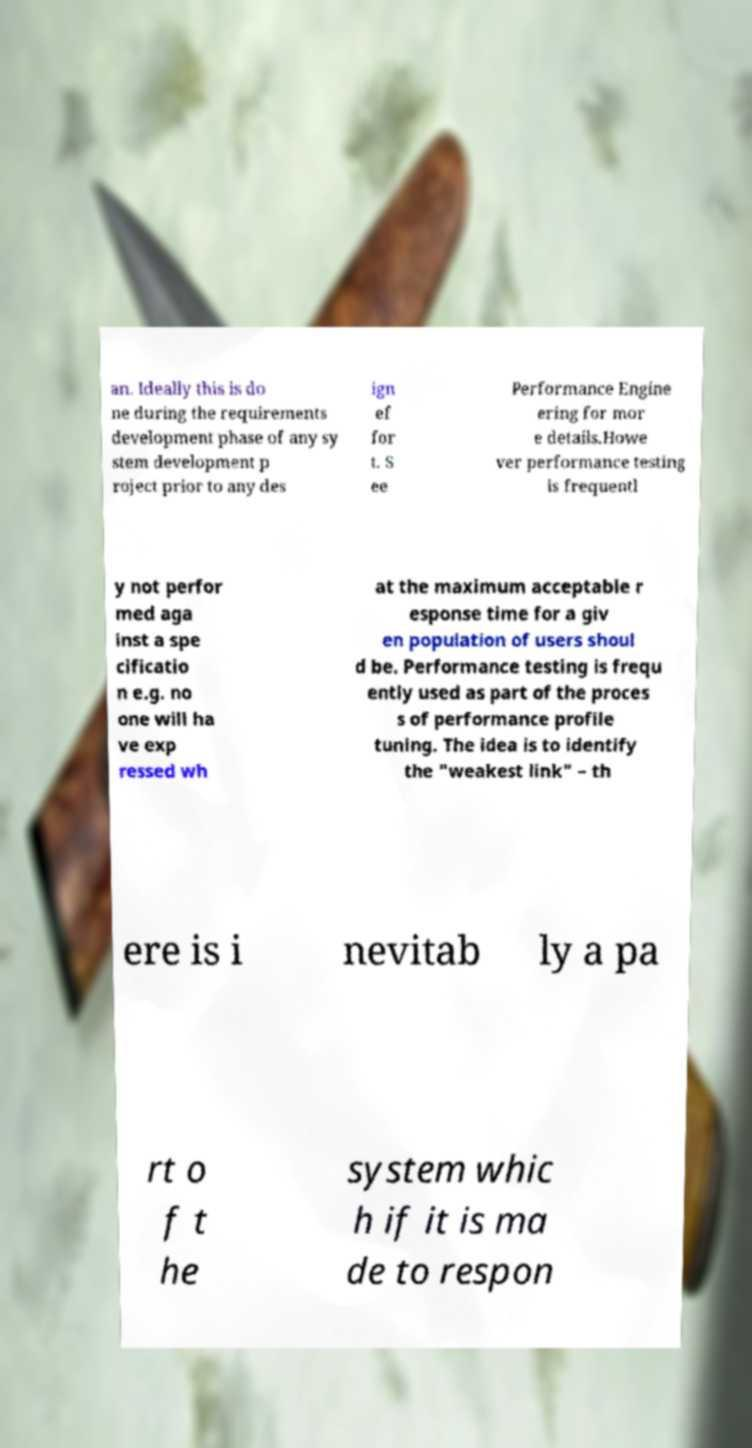For documentation purposes, I need the text within this image transcribed. Could you provide that? an. Ideally this is do ne during the requirements development phase of any sy stem development p roject prior to any des ign ef for t. S ee Performance Engine ering for mor e details.Howe ver performance testing is frequentl y not perfor med aga inst a spe cificatio n e.g. no one will ha ve exp ressed wh at the maximum acceptable r esponse time for a giv en population of users shoul d be. Performance testing is frequ ently used as part of the proces s of performance profile tuning. The idea is to identify the "weakest link" – th ere is i nevitab ly a pa rt o f t he system whic h if it is ma de to respon 